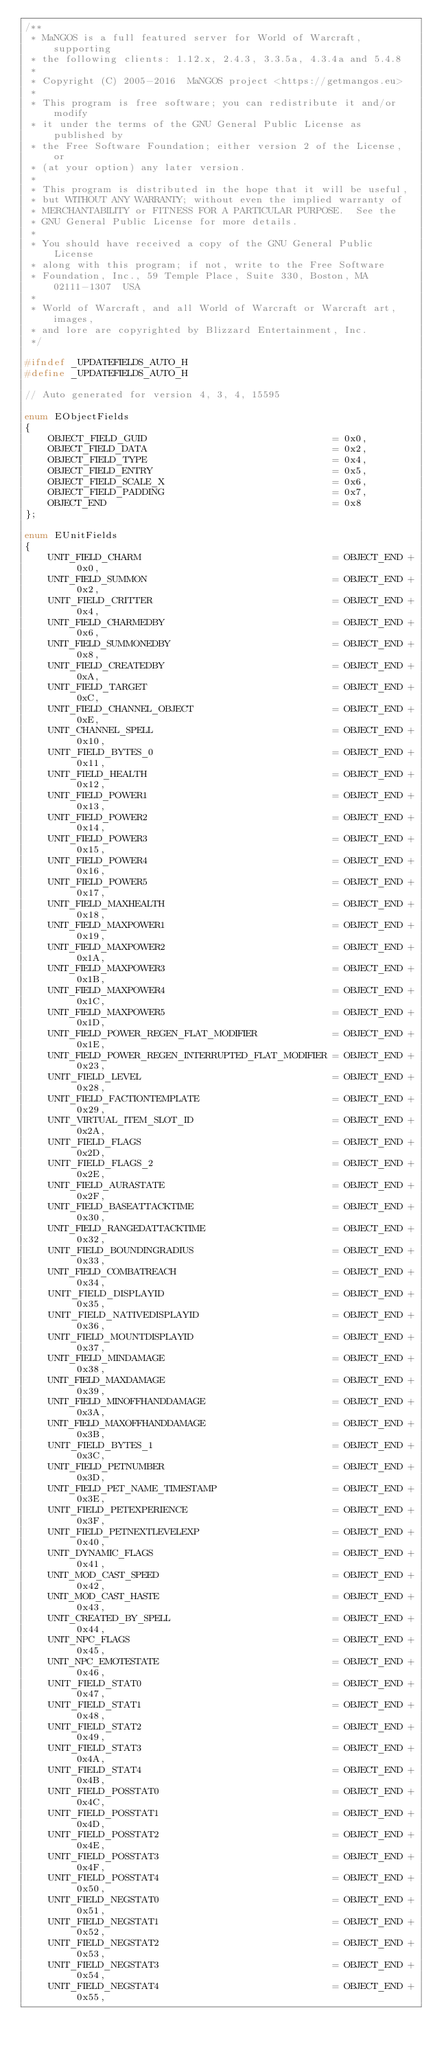Convert code to text. <code><loc_0><loc_0><loc_500><loc_500><_C_>/**
 * MaNGOS is a full featured server for World of Warcraft, supporting
 * the following clients: 1.12.x, 2.4.3, 3.3.5a, 4.3.4a and 5.4.8
 *
 * Copyright (C) 2005-2016  MaNGOS project <https://getmangos.eu>
 *
 * This program is free software; you can redistribute it and/or modify
 * it under the terms of the GNU General Public License as published by
 * the Free Software Foundation; either version 2 of the License, or
 * (at your option) any later version.
 *
 * This program is distributed in the hope that it will be useful,
 * but WITHOUT ANY WARRANTY; without even the implied warranty of
 * MERCHANTABILITY or FITNESS FOR A PARTICULAR PURPOSE.  See the
 * GNU General Public License for more details.
 *
 * You should have received a copy of the GNU General Public License
 * along with this program; if not, write to the Free Software
 * Foundation, Inc., 59 Temple Place, Suite 330, Boston, MA  02111-1307  USA
 *
 * World of Warcraft, and all World of Warcraft or Warcraft art, images,
 * and lore are copyrighted by Blizzard Entertainment, Inc.
 */

#ifndef _UPDATEFIELDS_AUTO_H
#define _UPDATEFIELDS_AUTO_H

// Auto generated for version 4, 3, 4, 15595

enum EObjectFields
{
    OBJECT_FIELD_GUID                                = 0x0,
    OBJECT_FIELD_DATA                                = 0x2,
    OBJECT_FIELD_TYPE                                = 0x4,
    OBJECT_FIELD_ENTRY                               = 0x5,
    OBJECT_FIELD_SCALE_X                             = 0x6,
    OBJECT_FIELD_PADDING                             = 0x7,
    OBJECT_END                                       = 0x8
};

enum EUnitFields
{
    UNIT_FIELD_CHARM                                 = OBJECT_END + 0x0,
    UNIT_FIELD_SUMMON                                = OBJECT_END + 0x2,
    UNIT_FIELD_CRITTER                               = OBJECT_END + 0x4,
    UNIT_FIELD_CHARMEDBY                             = OBJECT_END + 0x6,
    UNIT_FIELD_SUMMONEDBY                            = OBJECT_END + 0x8,
    UNIT_FIELD_CREATEDBY                             = OBJECT_END + 0xA,
    UNIT_FIELD_TARGET                                = OBJECT_END + 0xC,
    UNIT_FIELD_CHANNEL_OBJECT                        = OBJECT_END + 0xE,
    UNIT_CHANNEL_SPELL                               = OBJECT_END + 0x10,
    UNIT_FIELD_BYTES_0                               = OBJECT_END + 0x11,
    UNIT_FIELD_HEALTH                                = OBJECT_END + 0x12,
    UNIT_FIELD_POWER1                                = OBJECT_END + 0x13,
    UNIT_FIELD_POWER2                                = OBJECT_END + 0x14,
    UNIT_FIELD_POWER3                                = OBJECT_END + 0x15,
    UNIT_FIELD_POWER4                                = OBJECT_END + 0x16,
    UNIT_FIELD_POWER5                                = OBJECT_END + 0x17,
    UNIT_FIELD_MAXHEALTH                             = OBJECT_END + 0x18,
    UNIT_FIELD_MAXPOWER1                             = OBJECT_END + 0x19,
    UNIT_FIELD_MAXPOWER2                             = OBJECT_END + 0x1A,
    UNIT_FIELD_MAXPOWER3                             = OBJECT_END + 0x1B,
    UNIT_FIELD_MAXPOWER4                             = OBJECT_END + 0x1C,
    UNIT_FIELD_MAXPOWER5                             = OBJECT_END + 0x1D,
    UNIT_FIELD_POWER_REGEN_FLAT_MODIFIER             = OBJECT_END + 0x1E,
    UNIT_FIELD_POWER_REGEN_INTERRUPTED_FLAT_MODIFIER = OBJECT_END + 0x23,
    UNIT_FIELD_LEVEL                                 = OBJECT_END + 0x28,
    UNIT_FIELD_FACTIONTEMPLATE                       = OBJECT_END + 0x29,
    UNIT_VIRTUAL_ITEM_SLOT_ID                        = OBJECT_END + 0x2A,
    UNIT_FIELD_FLAGS                                 = OBJECT_END + 0x2D,
    UNIT_FIELD_FLAGS_2                               = OBJECT_END + 0x2E,
    UNIT_FIELD_AURASTATE                             = OBJECT_END + 0x2F,
    UNIT_FIELD_BASEATTACKTIME                        = OBJECT_END + 0x30,
    UNIT_FIELD_RANGEDATTACKTIME                      = OBJECT_END + 0x32,
    UNIT_FIELD_BOUNDINGRADIUS                        = OBJECT_END + 0x33,
    UNIT_FIELD_COMBATREACH                           = OBJECT_END + 0x34,
    UNIT_FIELD_DISPLAYID                             = OBJECT_END + 0x35,
    UNIT_FIELD_NATIVEDISPLAYID                       = OBJECT_END + 0x36,
    UNIT_FIELD_MOUNTDISPLAYID                        = OBJECT_END + 0x37,
    UNIT_FIELD_MINDAMAGE                             = OBJECT_END + 0x38,
    UNIT_FIELD_MAXDAMAGE                             = OBJECT_END + 0x39,
    UNIT_FIELD_MINOFFHANDDAMAGE                      = OBJECT_END + 0x3A,
    UNIT_FIELD_MAXOFFHANDDAMAGE                      = OBJECT_END + 0x3B,
    UNIT_FIELD_BYTES_1                               = OBJECT_END + 0x3C,
    UNIT_FIELD_PETNUMBER                             = OBJECT_END + 0x3D,
    UNIT_FIELD_PET_NAME_TIMESTAMP                    = OBJECT_END + 0x3E,
    UNIT_FIELD_PETEXPERIENCE                         = OBJECT_END + 0x3F,
    UNIT_FIELD_PETNEXTLEVELEXP                       = OBJECT_END + 0x40,
    UNIT_DYNAMIC_FLAGS                               = OBJECT_END + 0x41,
    UNIT_MOD_CAST_SPEED                              = OBJECT_END + 0x42,
    UNIT_MOD_CAST_HASTE                              = OBJECT_END + 0x43,
    UNIT_CREATED_BY_SPELL                            = OBJECT_END + 0x44,
    UNIT_NPC_FLAGS                                   = OBJECT_END + 0x45,
    UNIT_NPC_EMOTESTATE                              = OBJECT_END + 0x46,
    UNIT_FIELD_STAT0                                 = OBJECT_END + 0x47,
    UNIT_FIELD_STAT1                                 = OBJECT_END + 0x48,
    UNIT_FIELD_STAT2                                 = OBJECT_END + 0x49,
    UNIT_FIELD_STAT3                                 = OBJECT_END + 0x4A,
    UNIT_FIELD_STAT4                                 = OBJECT_END + 0x4B,
    UNIT_FIELD_POSSTAT0                              = OBJECT_END + 0x4C,
    UNIT_FIELD_POSSTAT1                              = OBJECT_END + 0x4D,
    UNIT_FIELD_POSSTAT2                              = OBJECT_END + 0x4E,
    UNIT_FIELD_POSSTAT3                              = OBJECT_END + 0x4F,
    UNIT_FIELD_POSSTAT4                              = OBJECT_END + 0x50,
    UNIT_FIELD_NEGSTAT0                              = OBJECT_END + 0x51,
    UNIT_FIELD_NEGSTAT1                              = OBJECT_END + 0x52,
    UNIT_FIELD_NEGSTAT2                              = OBJECT_END + 0x53,
    UNIT_FIELD_NEGSTAT3                              = OBJECT_END + 0x54,
    UNIT_FIELD_NEGSTAT4                              = OBJECT_END + 0x55,</code> 